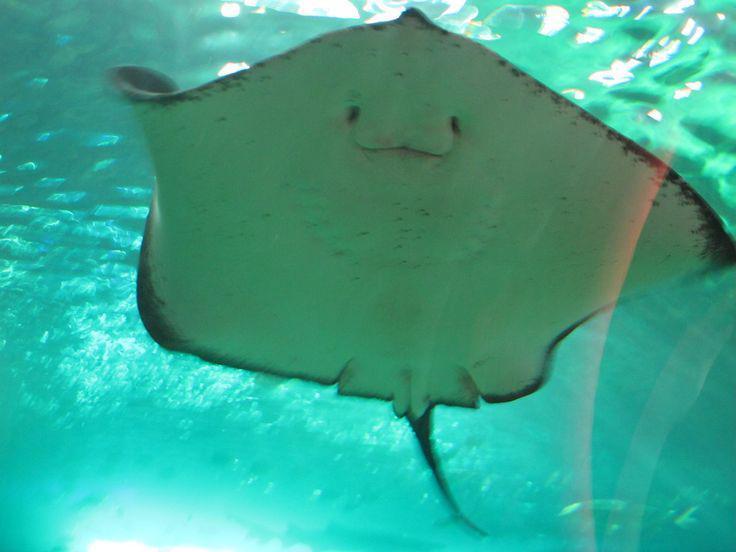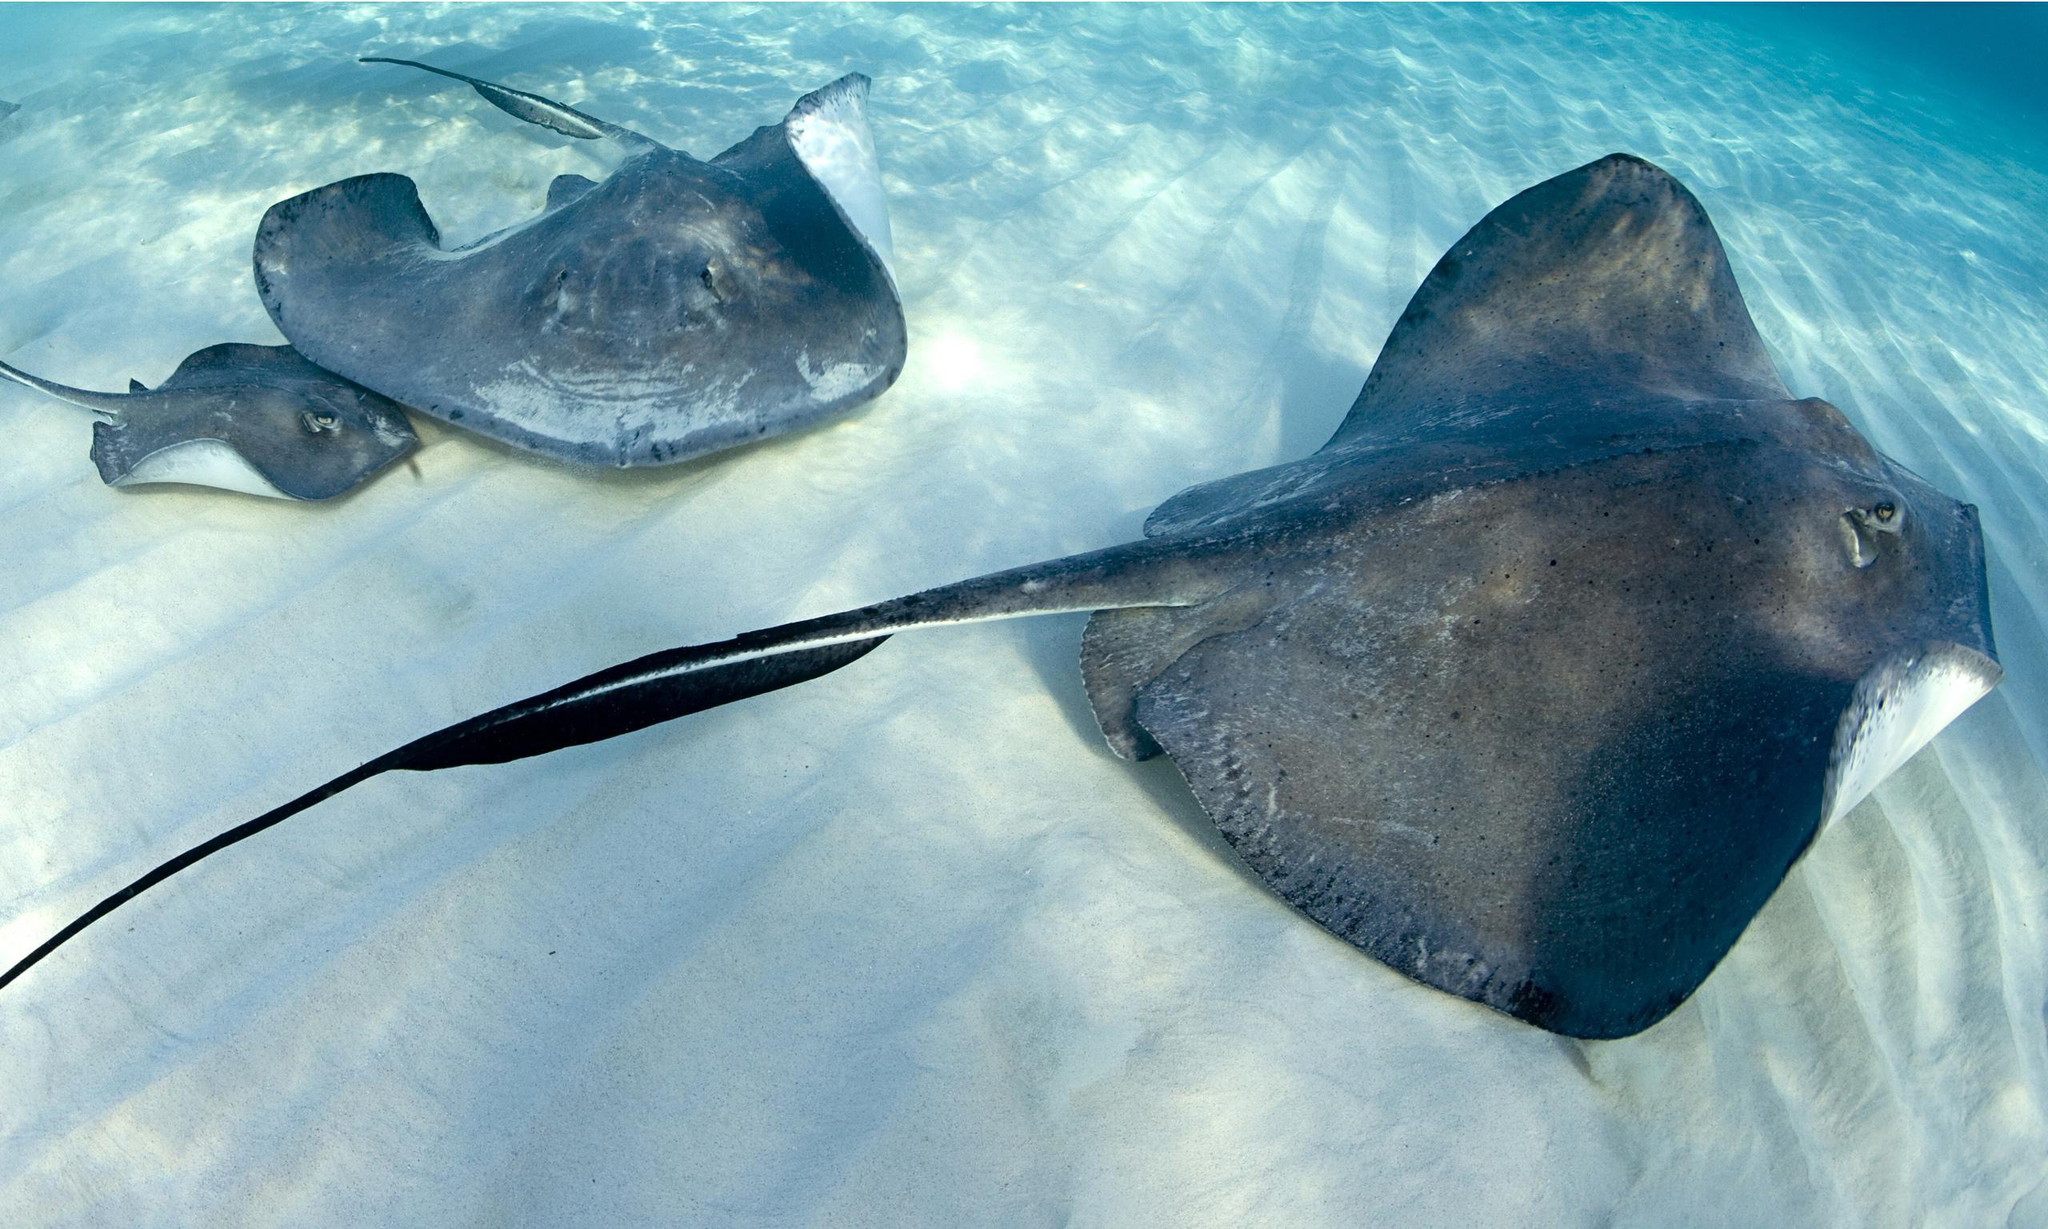The first image is the image on the left, the second image is the image on the right. Evaluate the accuracy of this statement regarding the images: "The creature in the image on the left appears to be smiling.". Is it true? Answer yes or no. Yes. 